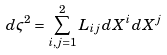Convert formula to latex. <formula><loc_0><loc_0><loc_500><loc_500>d \varsigma ^ { 2 } = \sum _ { i , j = 1 } ^ { 2 } L _ { i j } d X ^ { i } d X ^ { j }</formula> 